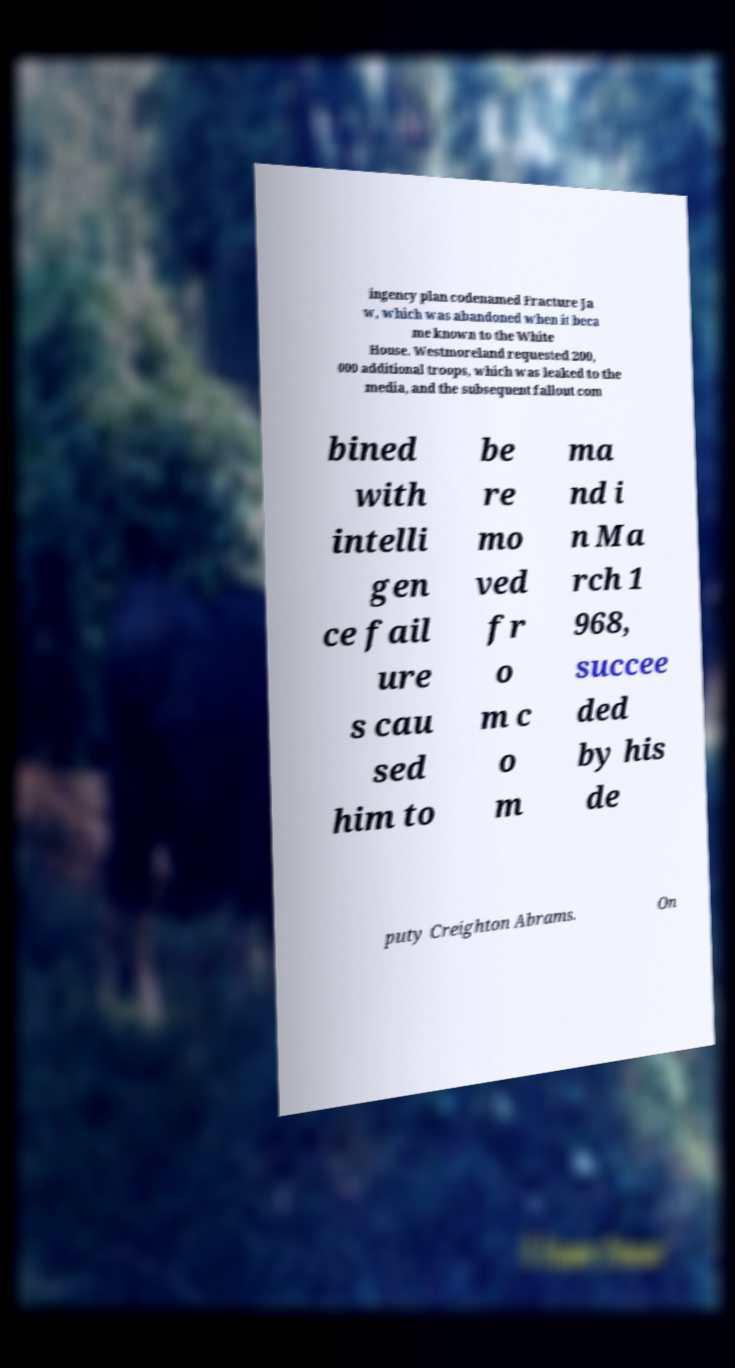Could you extract and type out the text from this image? ingency plan codenamed Fracture Ja w, which was abandoned when it beca me known to the White House. Westmoreland requested 200, 000 additional troops, which was leaked to the media, and the subsequent fallout com bined with intelli gen ce fail ure s cau sed him to be re mo ved fr o m c o m ma nd i n Ma rch 1 968, succee ded by his de puty Creighton Abrams. On 